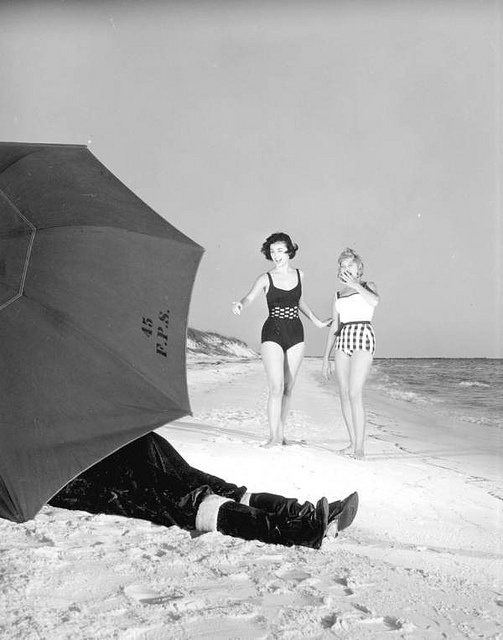Describe the objects in this image and their specific colors. I can see umbrella in dimgray, gray, black, darkgray, and lightgray tones, people in dimgray, black, gray, lightgray, and darkgray tones, people in dimgray, lightgray, black, gray, and darkgray tones, and people in dimgray, lightgray, darkgray, gray, and black tones in this image. 